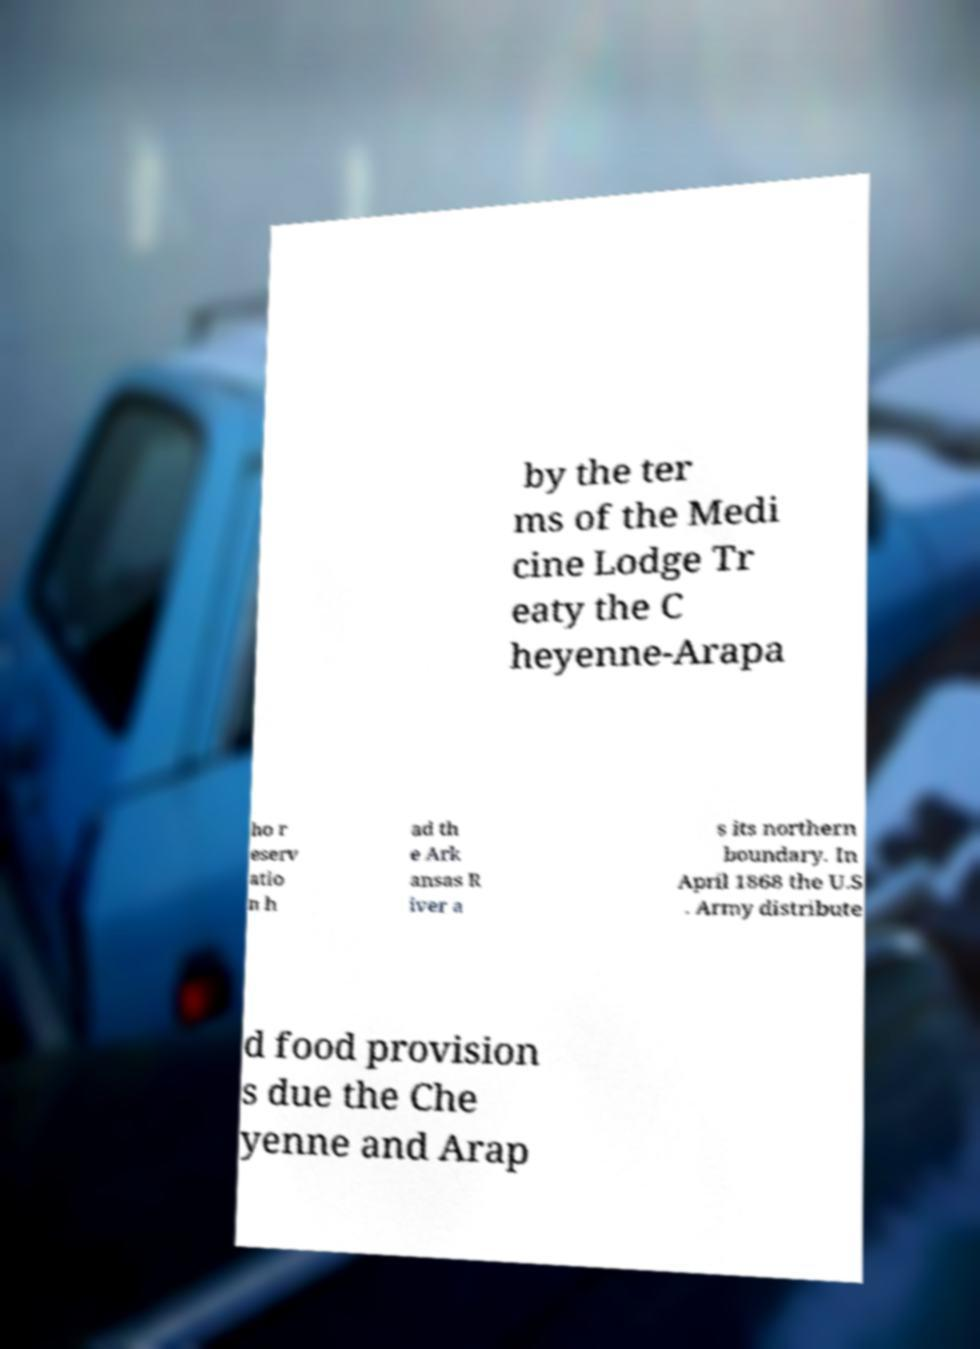Could you assist in decoding the text presented in this image and type it out clearly? by the ter ms of the Medi cine Lodge Tr eaty the C heyenne-Arapa ho r eserv atio n h ad th e Ark ansas R iver a s its northern boundary. In April 1868 the U.S . Army distribute d food provision s due the Che yenne and Arap 